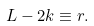<formula> <loc_0><loc_0><loc_500><loc_500>L - 2 k \equiv r .</formula> 